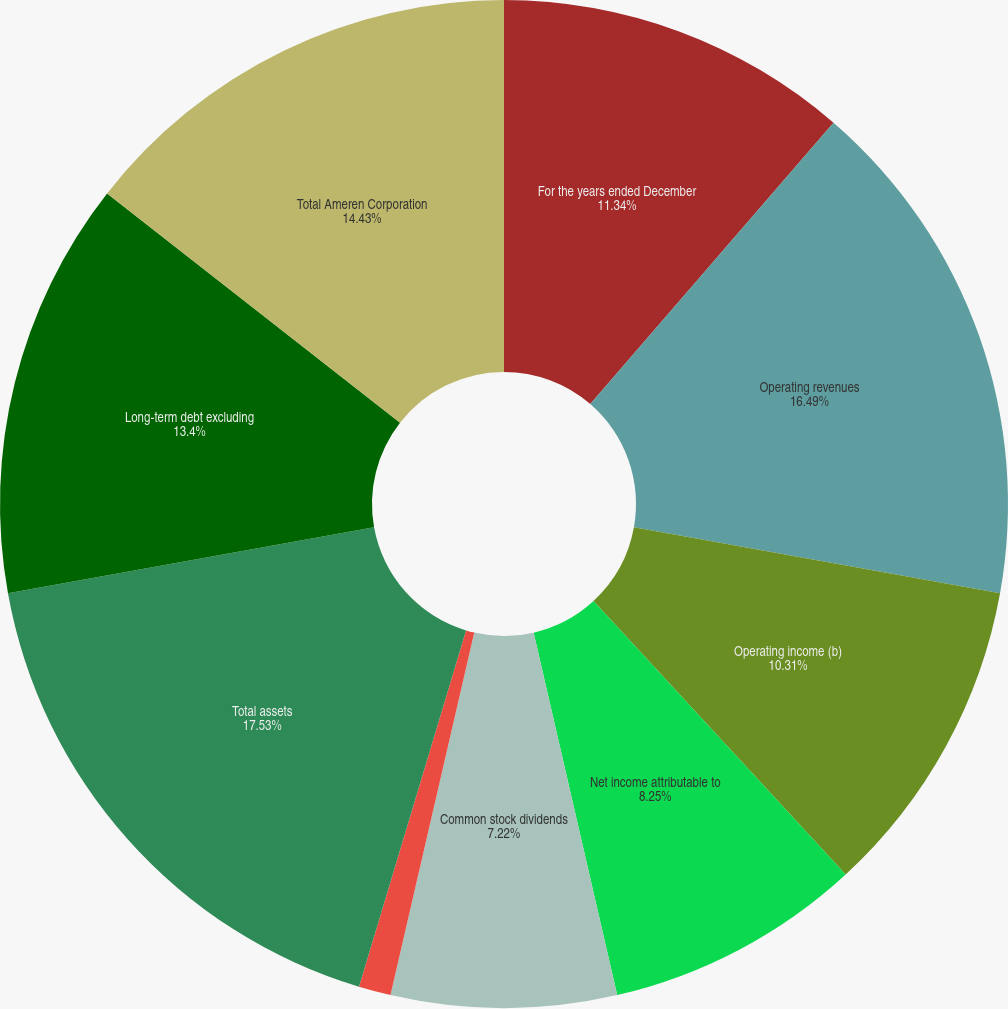Convert chart. <chart><loc_0><loc_0><loc_500><loc_500><pie_chart><fcel>For the years ended December<fcel>Operating revenues<fcel>Operating income (b)<fcel>Net income attributable to<fcel>Common stock dividends<fcel>Earnings per share - basic and<fcel>Common stock dividends per<fcel>Total assets<fcel>Long-term debt excluding<fcel>Total Ameren Corporation<nl><fcel>11.34%<fcel>16.49%<fcel>10.31%<fcel>8.25%<fcel>7.22%<fcel>1.03%<fcel>0.0%<fcel>17.52%<fcel>13.4%<fcel>14.43%<nl></chart> 